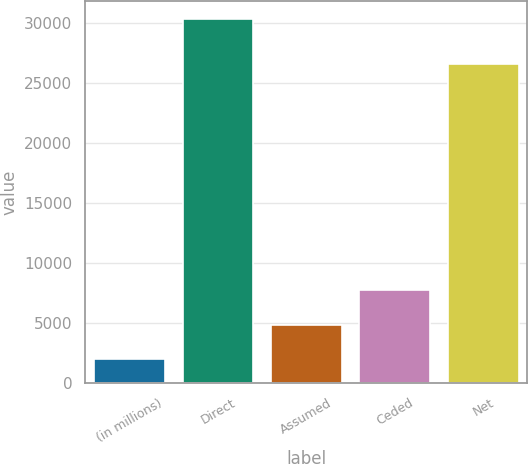Convert chart. <chart><loc_0><loc_0><loc_500><loc_500><bar_chart><fcel>(in millions)<fcel>Direct<fcel>Assumed<fcel>Ceded<fcel>Net<nl><fcel>2018<fcel>30335<fcel>4849.7<fcel>7755<fcel>26606<nl></chart> 